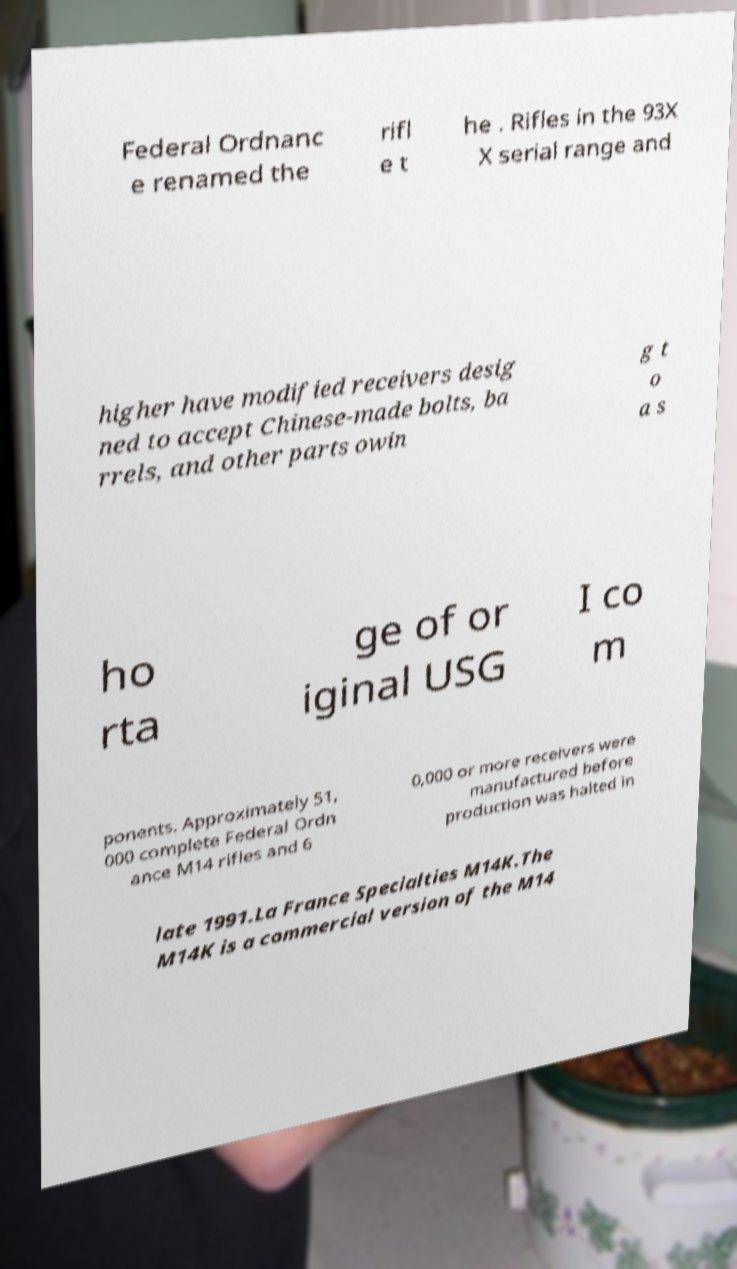Please identify and transcribe the text found in this image. Federal Ordnanc e renamed the rifl e t he . Rifles in the 93X X serial range and higher have modified receivers desig ned to accept Chinese-made bolts, ba rrels, and other parts owin g t o a s ho rta ge of or iginal USG I co m ponents. Approximately 51, 000 complete Federal Ordn ance M14 rifles and 6 0,000 or more receivers were manufactured before production was halted in late 1991.La France Specialties M14K.The M14K is a commercial version of the M14 